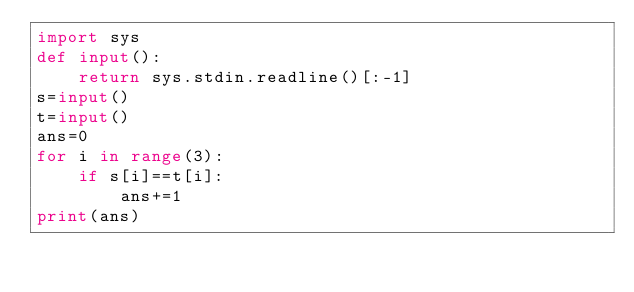<code> <loc_0><loc_0><loc_500><loc_500><_Python_>import sys
def input():
    return sys.stdin.readline()[:-1]
s=input()
t=input()
ans=0
for i in range(3):
    if s[i]==t[i]:
        ans+=1
print(ans)</code> 